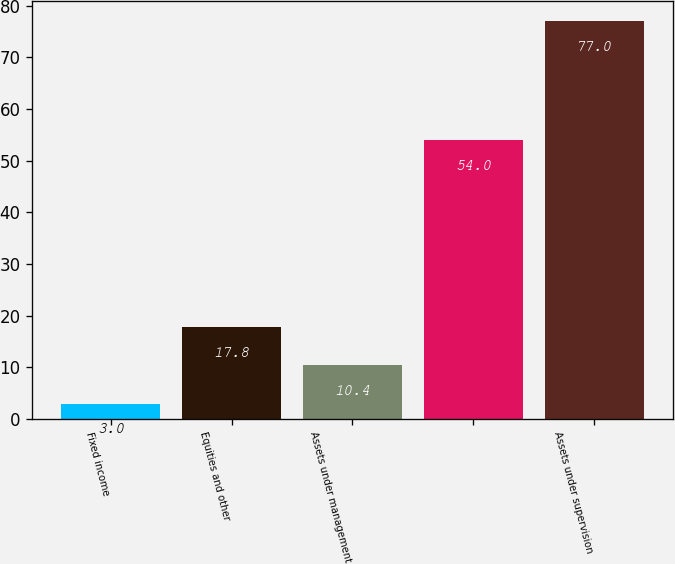<chart> <loc_0><loc_0><loc_500><loc_500><bar_chart><fcel>Fixed income<fcel>Equities and other<fcel>Assets under management<fcel>Unnamed: 3<fcel>Assets under supervision<nl><fcel>3<fcel>17.8<fcel>10.4<fcel>54<fcel>77<nl></chart> 